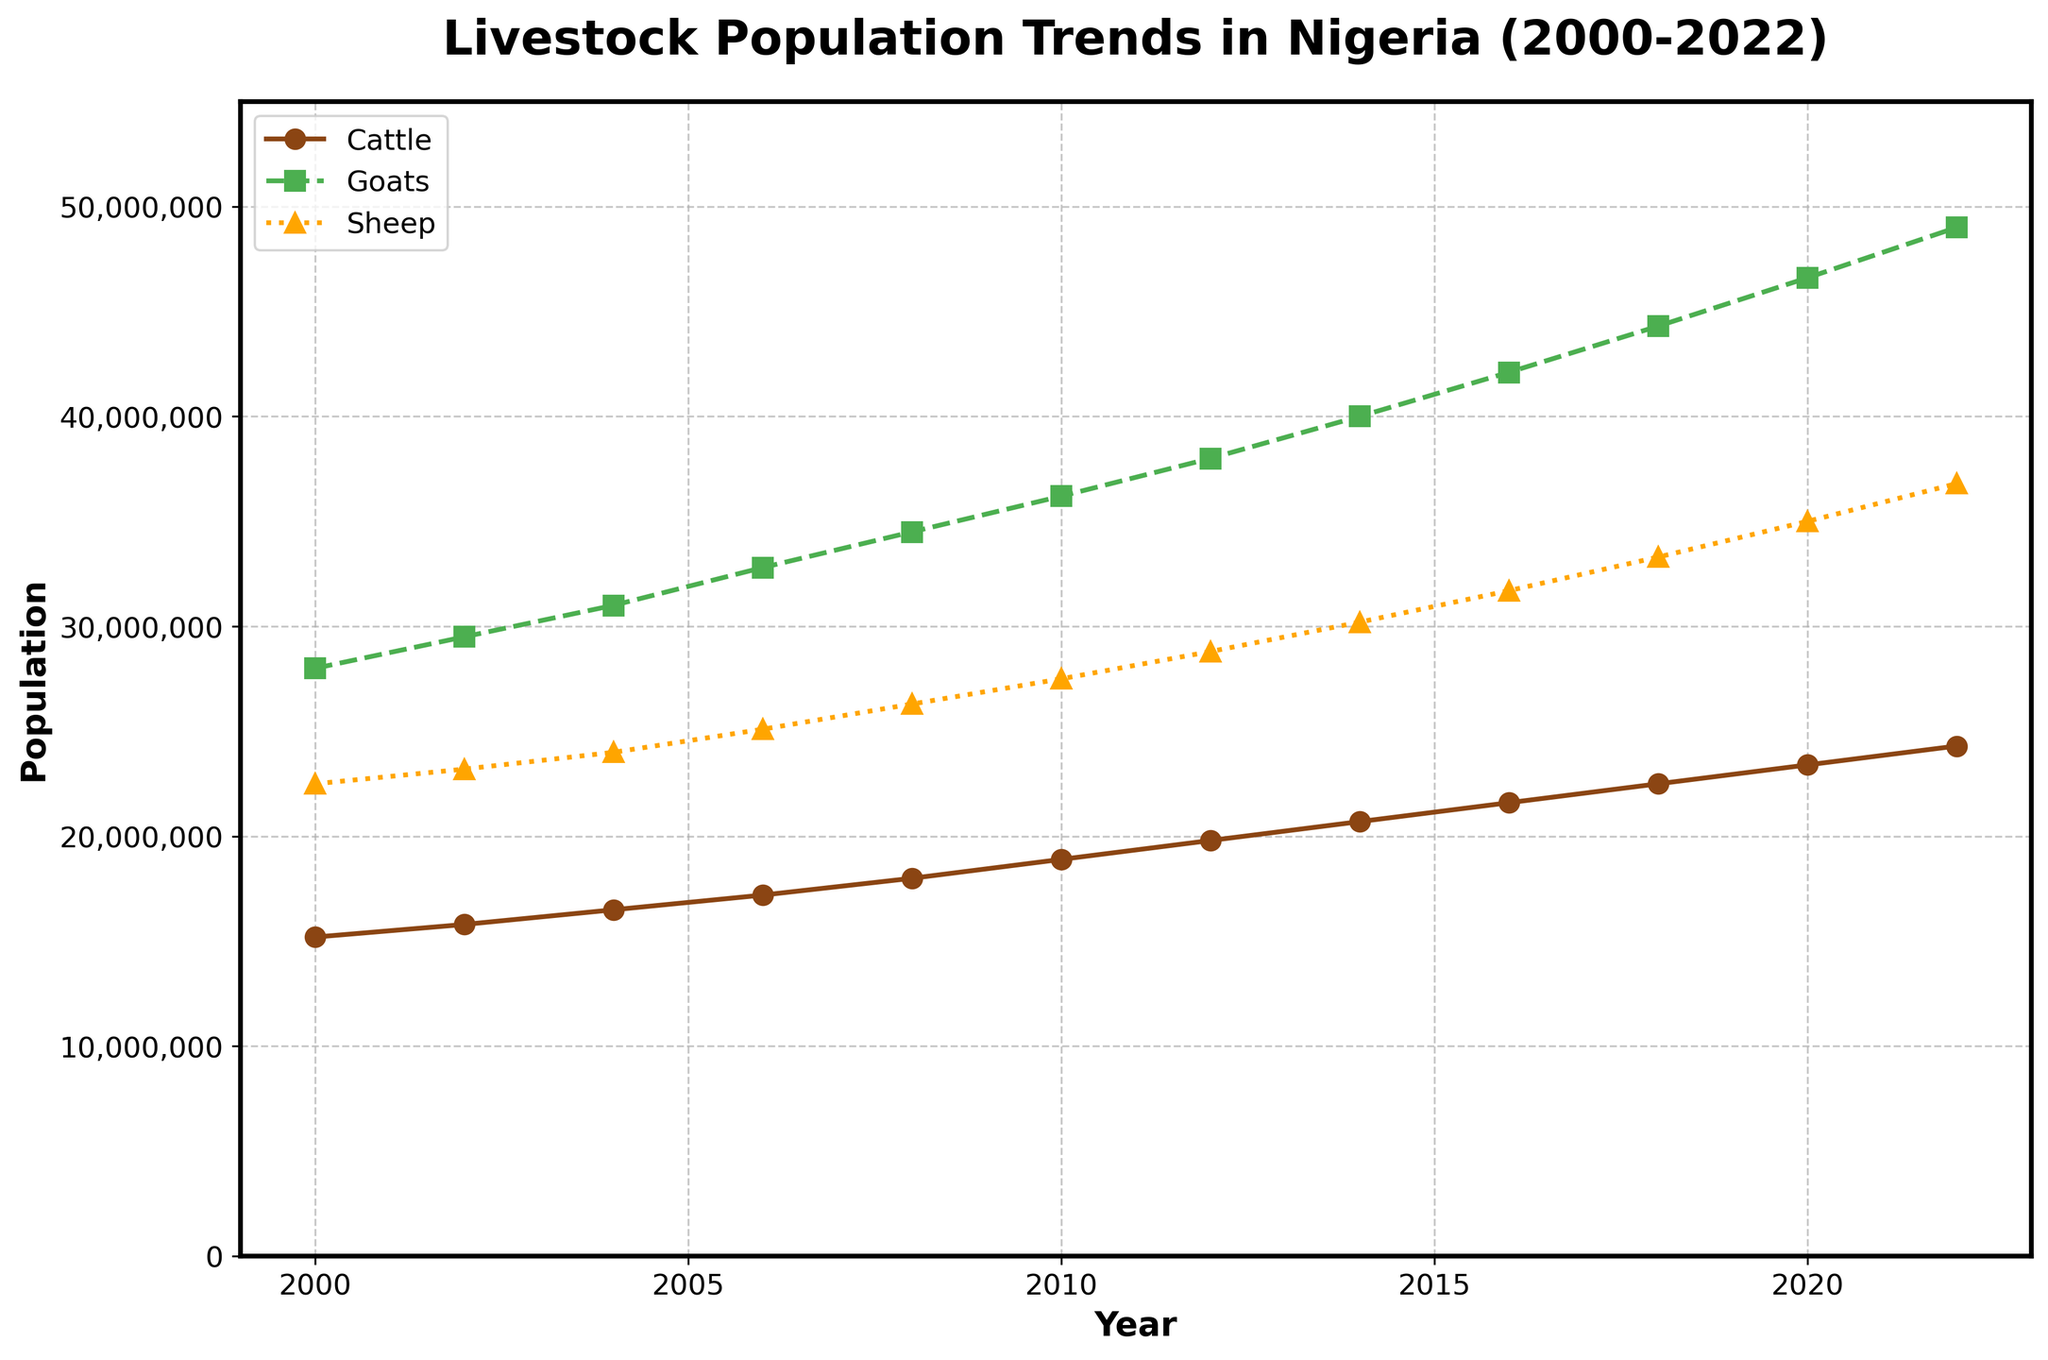What is the population growth of cattle from 2000 to 2022? To determine the population growth of cattle from 2000 to 2022, subtract the population in 2000 from the population in 2022. This is 24,300,000 (in 2022) - 15,200,000 (in 2000), which equals 9,100,000.
Answer: 9,100,000 Which livestock type had the highest population in 2010? Look at the values for livestock populations in 2010 and find the highest one. The populations are: Cattle: 18,900,000; Goats: 36,200,000; Sheep: 27,500,000. Goats have the highest population.
Answer: Goats Which year saw the smallest population for sheep? Compare the population of sheep across all the years presented and identify the year with the lowest value. The smallest population for sheep is 22,500,000 in the year 2000.
Answer: 2000 Between goats and sheep, which had a higher rate of increase in population from 2008 to 2014? Calculate the rate of increase for goats and sheep by finding the difference in their populations between 2008 and 2014, and then compare the results. For goats: 40,000,000 (2014) - 34,500,000 (2008) = 5,500,000. For sheep: 30,200,000 (2014) - 26,300,000 (2008) = 3,900,000. Goats had a higher rate of increase.
Answer: Goats What color represents the sheep population on the plot? Identify the color used for the line representing sheep. The sheep population is represented by an orange line.
Answer: Orange What was the total livestock population for cattle, goats, and sheep in 2016? Add the populations of cattle, goats, and sheep for the year 2016. This is 21,600,000 (cattle) + 42,100,000 (goats) + 31,700,000 (sheep) = 95,400,000.
Answer: 95,400,000 During which time period did cattle see the largest increase in population? To find the largest increase, compare the population increases between consecutive data points. The time period with the largest increase is from 2018 to 2020, with an increase of 2,400,000 (23,400,000 in 2020 - 22,500,000 in 2018).
Answer: 2018-2020 What were the average populations of goats and sheep over the entire period? Calculate the average by summing the populations for each year and dividing by the number of years (12 years given in the data). For goats: (sum of goats population) ÷ 12 and for sheep: (sum of sheep population) ÷ 12. The averaging gives approximately, goats: 36916667 and sheep: 29200000.
Answer: Goats: 36,916,667; Sheep: 29,200,000 